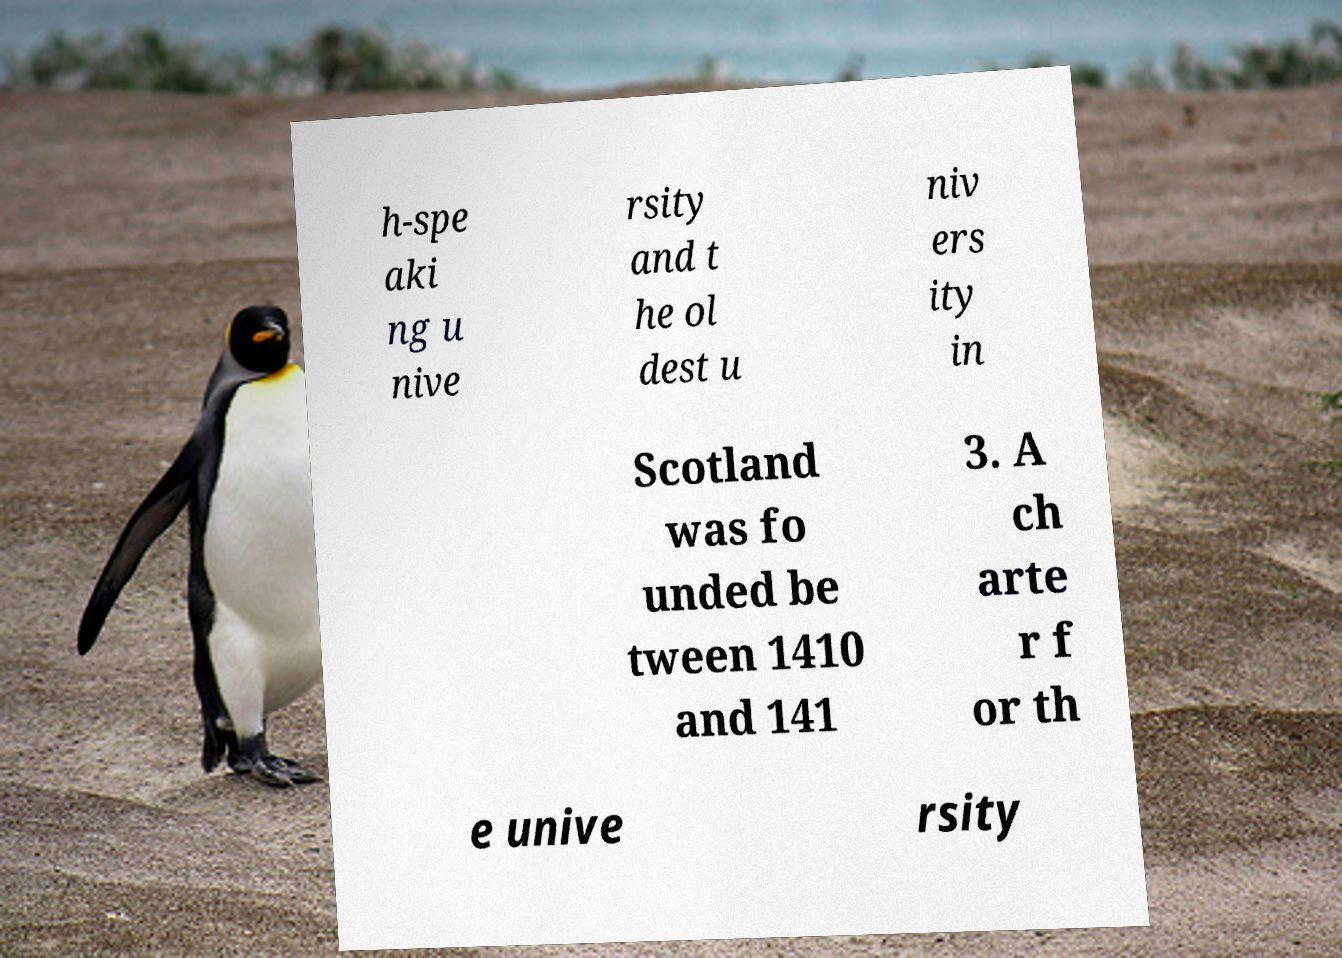Could you extract and type out the text from this image? h-spe aki ng u nive rsity and t he ol dest u niv ers ity in Scotland was fo unded be tween 1410 and 141 3. A ch arte r f or th e unive rsity 